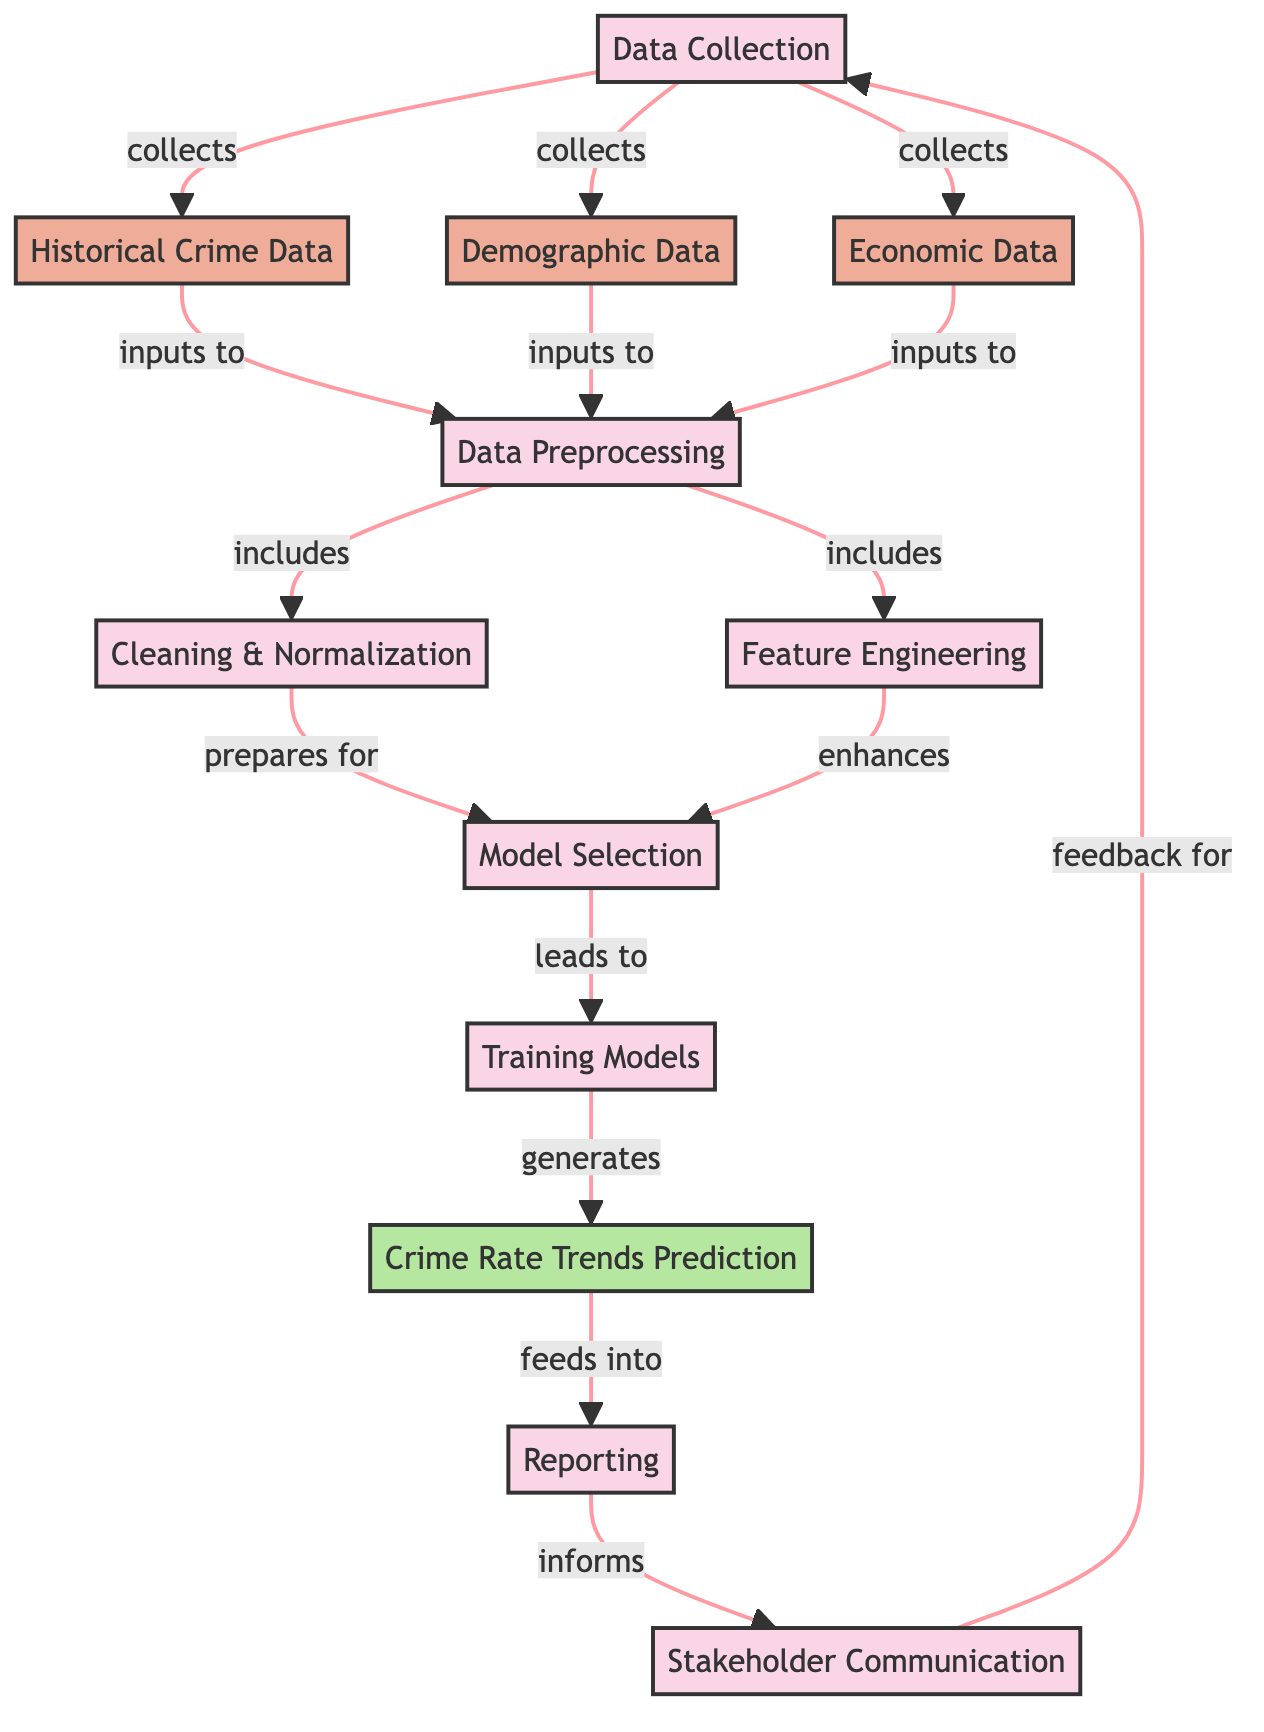What is the starting point of the flow in the diagram? The starting point of the flow is the "Data Collection" node, which initiates the process by collecting various types of data.
Answer: Data Collection How many types of data are collected in the first step? In the first step, three types of data are collected: Historical Crime Data, Demographic Data, and Economic Data.
Answer: Three What processes are involved in data preprocessing? The data preprocessing step includes two processes: "Cleaning & Normalization" and "Feature Engineering."
Answer: Cleaning & Normalization and Feature Engineering What leads to the training of models? The training of models is preceded by the "Model Selection," which is part of the data preprocessing flow. The process must be selected before any models can be trained.
Answer: Model Selection Which node generates the crime rate trends prediction? The node that generates the crime rate trends prediction is "Training Models," which produces the analysis results based on the models.
Answer: Training Models What is the final output of this diagram? The final output of this diagram is "Crime Rate Trends Prediction," which reflects the analysis done throughout the flow.
Answer: Crime Rate Trends Prediction What does the reporting node inform? The reporting node informs "Stakeholder Communication," implying that the results from reporting are meant to be communicated to stakeholders.
Answer: Stakeholder Communication How does the process loop back into data collection? The process loops back into data collection through feedback from "Stakeholder Communication," which may suggest new data needs or revisions in data collection.
Answer: Feedback Which process is emphasized with a bold font size? The process that is emphasized with a bold font size is "Crime Rate Trends Prediction," indicating its significance in the overall analysis flow.
Answer: Crime Rate Trends Prediction 